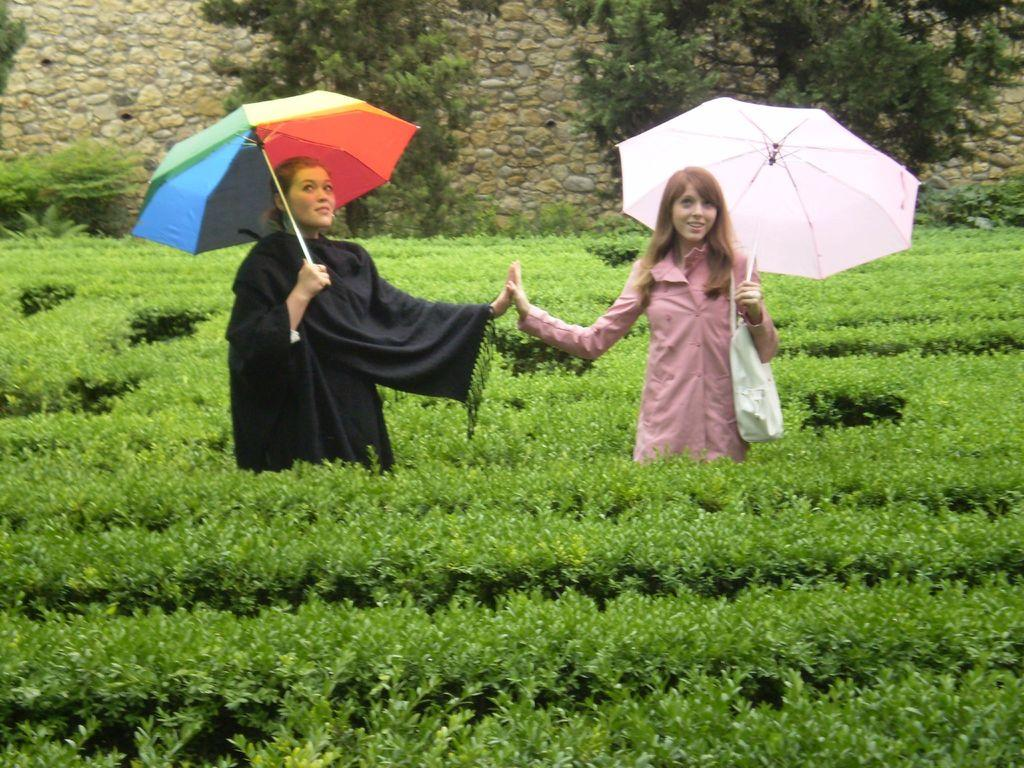What type of living organisms can be seen in the image? Plants can be seen in the image. How many women are in the image, and what are they holding? There are two women in the image, and they are holding umbrellas. What is the facial expression of the women in the image? The women are smiling. What is one woman carrying in the image? One woman is carrying a bag. What can be seen in the background of the image? There is a wall and trees in the background of the image. What type of silver object is visible in the image? There is no silver object present in the image. What hobbies do the women in the image enjoy? The provided facts do not give any information about the women's hobbies, so we cannot determine their hobbies from the image. 